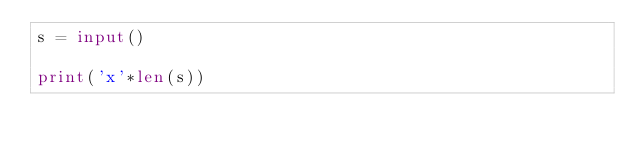<code> <loc_0><loc_0><loc_500><loc_500><_Python_>s = input()

print('x'*len(s))

</code> 